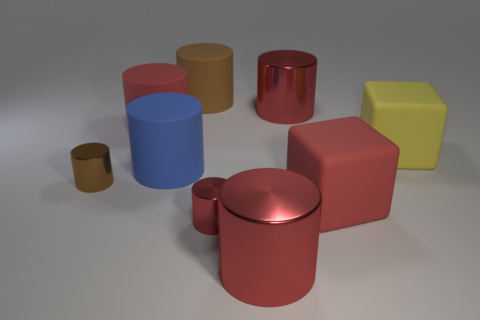Subtract all blue blocks. How many red cylinders are left? 4 Subtract all rubber cylinders. How many cylinders are left? 4 Subtract all blue cylinders. How many cylinders are left? 6 Subtract 3 cylinders. How many cylinders are left? 4 Subtract all cubes. How many objects are left? 7 Subtract all big blue cylinders. Subtract all small metallic objects. How many objects are left? 6 Add 5 large blue rubber cylinders. How many large blue rubber cylinders are left? 6 Add 6 large blue matte things. How many large blue matte things exist? 7 Subtract 0 purple spheres. How many objects are left? 9 Subtract all yellow cylinders. Subtract all green spheres. How many cylinders are left? 7 